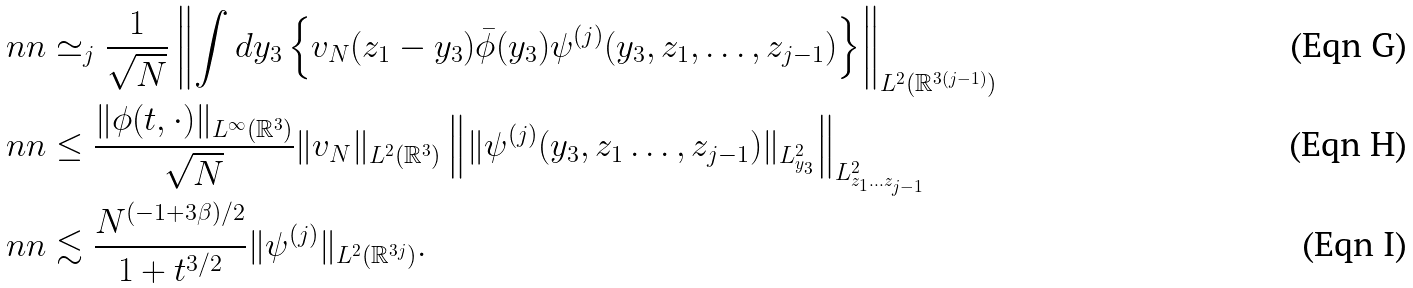Convert formula to latex. <formula><loc_0><loc_0><loc_500><loc_500>& \ n n \simeq _ { j } \frac { 1 } { \sqrt { N } } \left \| \int d y _ { 3 } \left \{ v _ { N } ( z _ { 1 } - y _ { 3 } ) \bar { \phi } ( y _ { 3 } ) \psi ^ { ( j ) } ( y _ { 3 } , z _ { 1 } , \dots , z _ { j - 1 } ) \right \} \right \| _ { L ^ { 2 } ( \mathbb { R } ^ { 3 ( j - 1 ) } ) } \\ & \ n n \leq \frac { \| \phi ( t , \cdot ) \| _ { L ^ { \infty } ( \mathbb { R } ^ { 3 } ) } } { \sqrt { N } } \| v _ { N } \| _ { L ^ { 2 } ( \mathbb { R } ^ { 3 } ) } \left \| \| \psi ^ { ( j ) } ( y _ { 3 } , z _ { 1 } \dots , z _ { j - 1 } ) \| _ { L ^ { 2 } _ { y _ { 3 } } } \right \| _ { L ^ { 2 } _ { z _ { 1 } \dots z _ { j - 1 } } } \\ & \ n n \lesssim \frac { N ^ { ( - 1 + 3 \beta ) / 2 } } { 1 + t ^ { 3 / 2 } } \| \psi ^ { ( j ) } \| _ { L ^ { 2 } ( \mathbb { R } ^ { 3 j } ) } .</formula> 